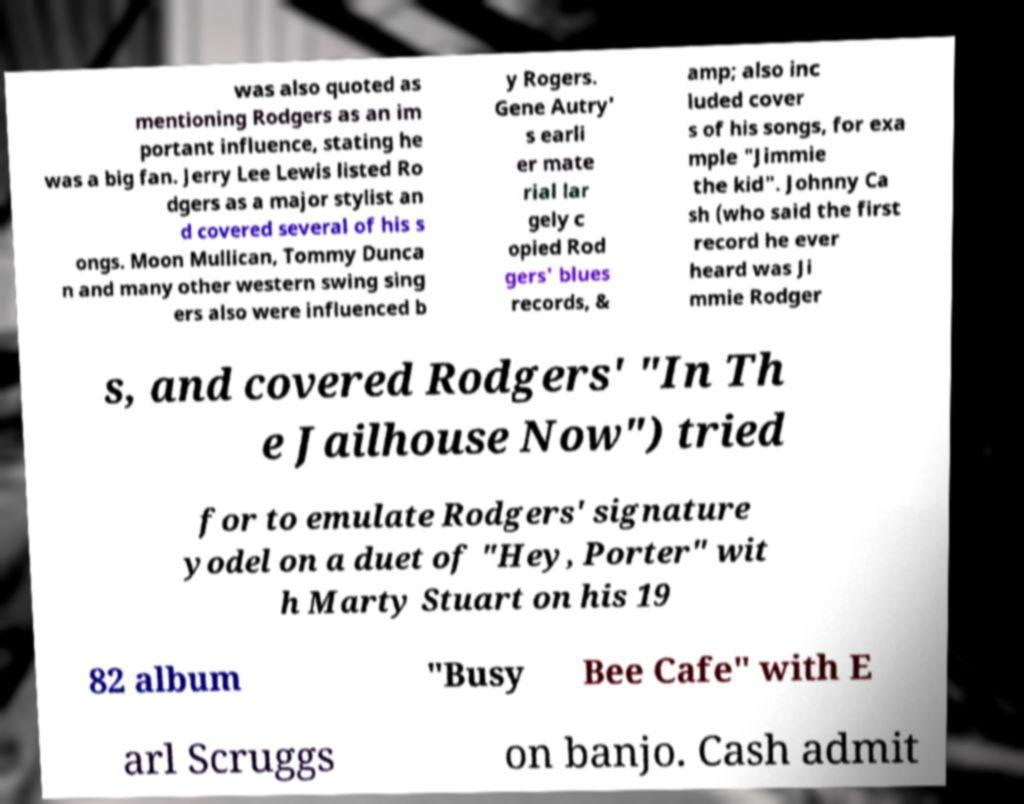I need the written content from this picture converted into text. Can you do that? was also quoted as mentioning Rodgers as an im portant influence, stating he was a big fan. Jerry Lee Lewis listed Ro dgers as a major stylist an d covered several of his s ongs. Moon Mullican, Tommy Dunca n and many other western swing sing ers also were influenced b y Rogers. Gene Autry' s earli er mate rial lar gely c opied Rod gers' blues records, & amp; also inc luded cover s of his songs, for exa mple "Jimmie the kid". Johnny Ca sh (who said the first record he ever heard was Ji mmie Rodger s, and covered Rodgers' "In Th e Jailhouse Now") tried for to emulate Rodgers' signature yodel on a duet of "Hey, Porter" wit h Marty Stuart on his 19 82 album "Busy Bee Cafe" with E arl Scruggs on banjo. Cash admit 